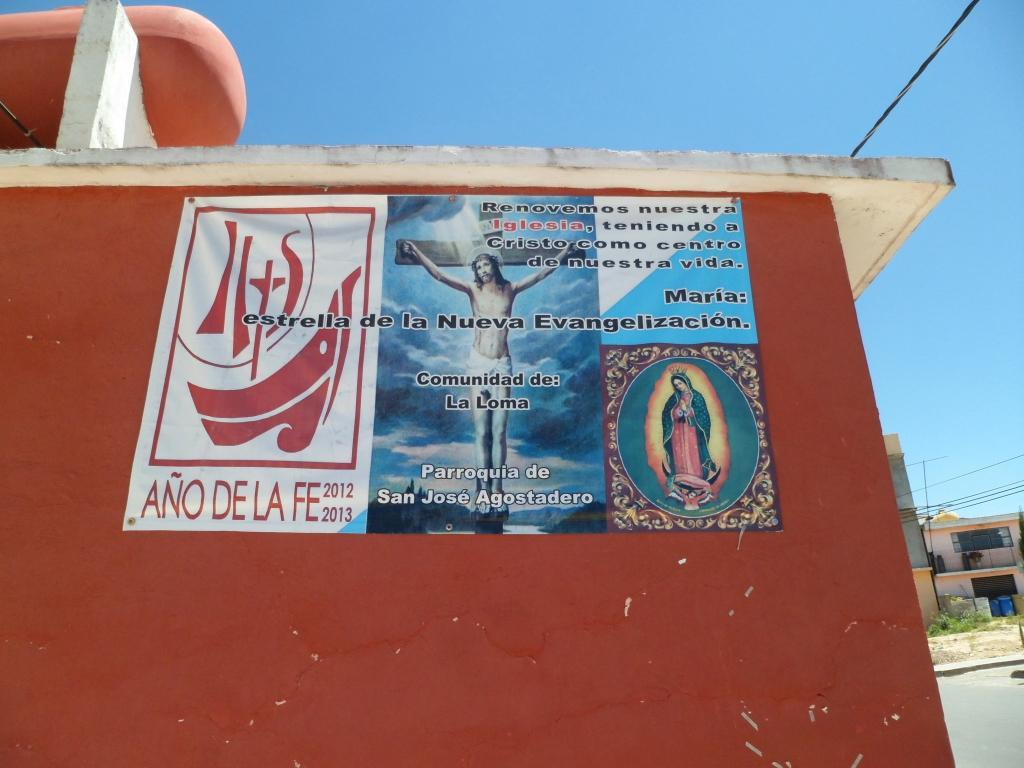Could you give a brief overview of what you see in this image? In this image we can see a poster with text and images on the wall of a building and in the background there are building and plants in front of the building, a pole with wires, a road and the sky. 